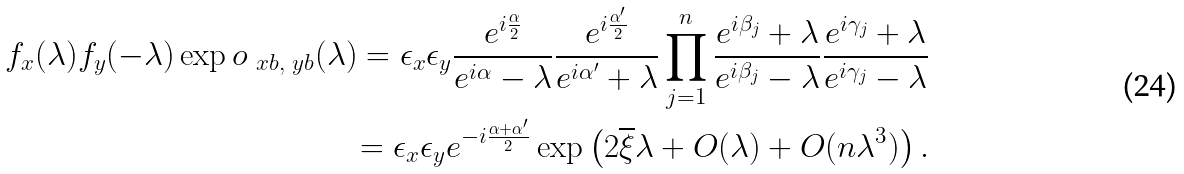Convert formula to latex. <formula><loc_0><loc_0><loc_500><loc_500>f _ { x } ( \lambda ) f _ { y } ( - \lambda ) \exp o _ { \ x b , \ y b } ( \lambda ) = \epsilon _ { x } \epsilon _ { y } \frac { e ^ { i \frac { \alpha } { 2 } } } { e ^ { i \alpha } - \lambda } \frac { e ^ { i \frac { \alpha ^ { \prime } } { 2 } } } { e ^ { i \alpha ^ { \prime } } + \lambda } \prod _ { j = 1 } ^ { n } \frac { e ^ { i \beta _ { j } } + \lambda } { e ^ { i \beta _ { j } } - \lambda } \frac { e ^ { i \gamma _ { j } } + \lambda } { e ^ { i \gamma _ { j } } - \lambda } \\ = \epsilon _ { x } \epsilon _ { y } e ^ { - i \frac { \alpha + \alpha ^ { \prime } } { 2 } } \exp \left ( 2 \overline { \xi } \lambda + O ( \lambda ) + O ( n \lambda ^ { 3 } ) \right ) .</formula> 